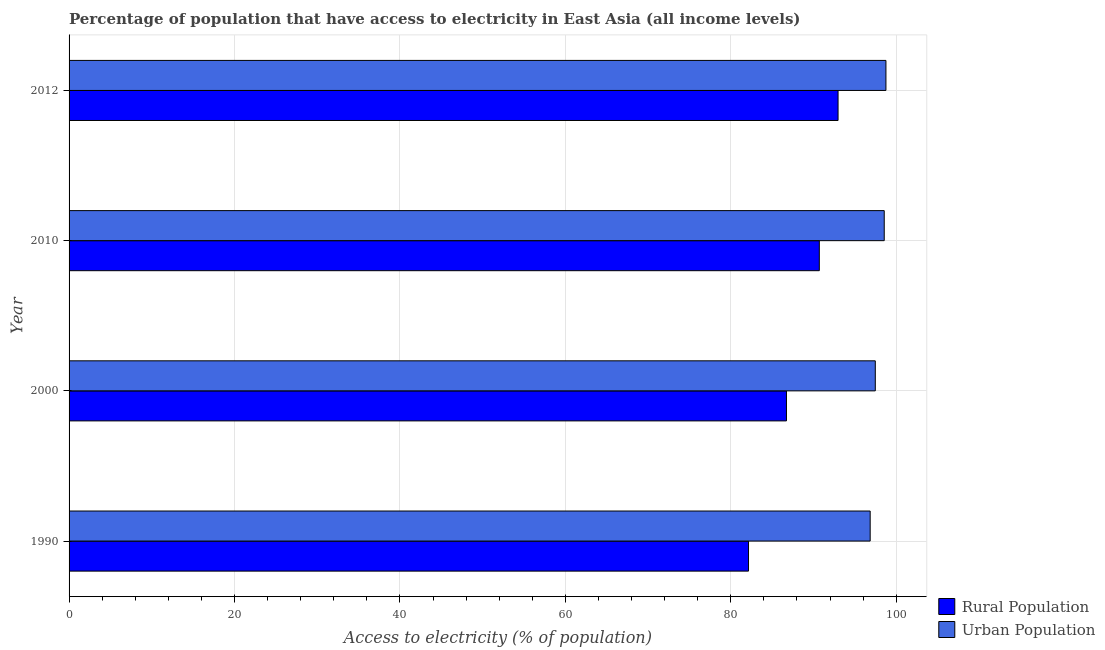Are the number of bars per tick equal to the number of legend labels?
Give a very brief answer. Yes. Are the number of bars on each tick of the Y-axis equal?
Your answer should be very brief. Yes. What is the label of the 2nd group of bars from the top?
Provide a succinct answer. 2010. In how many cases, is the number of bars for a given year not equal to the number of legend labels?
Your response must be concise. 0. What is the percentage of urban population having access to electricity in 2010?
Offer a terse response. 98.55. Across all years, what is the maximum percentage of urban population having access to electricity?
Your answer should be very brief. 98.76. Across all years, what is the minimum percentage of rural population having access to electricity?
Offer a terse response. 82.14. In which year was the percentage of urban population having access to electricity maximum?
Ensure brevity in your answer.  2012. What is the total percentage of urban population having access to electricity in the graph?
Provide a succinct answer. 391.62. What is the difference between the percentage of rural population having access to electricity in 2010 and that in 2012?
Your answer should be very brief. -2.27. What is the difference between the percentage of rural population having access to electricity in 2000 and the percentage of urban population having access to electricity in 2010?
Make the answer very short. -11.82. What is the average percentage of urban population having access to electricity per year?
Keep it short and to the point. 97.91. In the year 2012, what is the difference between the percentage of urban population having access to electricity and percentage of rural population having access to electricity?
Give a very brief answer. 5.79. In how many years, is the percentage of urban population having access to electricity greater than 44 %?
Offer a terse response. 4. What is the ratio of the percentage of urban population having access to electricity in 2010 to that in 2012?
Your answer should be compact. 1. What is the difference between the highest and the second highest percentage of urban population having access to electricity?
Your response must be concise. 0.21. What is the difference between the highest and the lowest percentage of urban population having access to electricity?
Your answer should be very brief. 1.9. In how many years, is the percentage of rural population having access to electricity greater than the average percentage of rural population having access to electricity taken over all years?
Offer a terse response. 2. What does the 1st bar from the top in 2010 represents?
Give a very brief answer. Urban Population. What does the 1st bar from the bottom in 2010 represents?
Give a very brief answer. Rural Population. How many bars are there?
Your answer should be very brief. 8. Are all the bars in the graph horizontal?
Your response must be concise. Yes. What is the difference between two consecutive major ticks on the X-axis?
Your answer should be very brief. 20. Does the graph contain any zero values?
Your answer should be very brief. No. How many legend labels are there?
Give a very brief answer. 2. How are the legend labels stacked?
Offer a very short reply. Vertical. What is the title of the graph?
Keep it short and to the point. Percentage of population that have access to electricity in East Asia (all income levels). What is the label or title of the X-axis?
Keep it short and to the point. Access to electricity (% of population). What is the label or title of the Y-axis?
Offer a terse response. Year. What is the Access to electricity (% of population) of Rural Population in 1990?
Your response must be concise. 82.14. What is the Access to electricity (% of population) in Urban Population in 1990?
Give a very brief answer. 96.85. What is the Access to electricity (% of population) in Rural Population in 2000?
Offer a very short reply. 86.73. What is the Access to electricity (% of population) in Urban Population in 2000?
Ensure brevity in your answer.  97.47. What is the Access to electricity (% of population) in Rural Population in 2010?
Your answer should be very brief. 90.7. What is the Access to electricity (% of population) in Urban Population in 2010?
Offer a very short reply. 98.55. What is the Access to electricity (% of population) in Rural Population in 2012?
Offer a very short reply. 92.97. What is the Access to electricity (% of population) of Urban Population in 2012?
Give a very brief answer. 98.76. Across all years, what is the maximum Access to electricity (% of population) of Rural Population?
Provide a short and direct response. 92.97. Across all years, what is the maximum Access to electricity (% of population) of Urban Population?
Your response must be concise. 98.76. Across all years, what is the minimum Access to electricity (% of population) in Rural Population?
Your answer should be very brief. 82.14. Across all years, what is the minimum Access to electricity (% of population) of Urban Population?
Make the answer very short. 96.85. What is the total Access to electricity (% of population) of Rural Population in the graph?
Make the answer very short. 352.54. What is the total Access to electricity (% of population) of Urban Population in the graph?
Provide a succinct answer. 391.62. What is the difference between the Access to electricity (% of population) in Rural Population in 1990 and that in 2000?
Ensure brevity in your answer.  -4.59. What is the difference between the Access to electricity (% of population) of Urban Population in 1990 and that in 2000?
Provide a short and direct response. -0.62. What is the difference between the Access to electricity (% of population) in Rural Population in 1990 and that in 2010?
Make the answer very short. -8.56. What is the difference between the Access to electricity (% of population) of Urban Population in 1990 and that in 2010?
Your answer should be compact. -1.7. What is the difference between the Access to electricity (% of population) in Rural Population in 1990 and that in 2012?
Keep it short and to the point. -10.83. What is the difference between the Access to electricity (% of population) of Urban Population in 1990 and that in 2012?
Provide a succinct answer. -1.9. What is the difference between the Access to electricity (% of population) of Rural Population in 2000 and that in 2010?
Provide a succinct answer. -3.97. What is the difference between the Access to electricity (% of population) of Urban Population in 2000 and that in 2010?
Offer a terse response. -1.08. What is the difference between the Access to electricity (% of population) in Rural Population in 2000 and that in 2012?
Your answer should be compact. -6.24. What is the difference between the Access to electricity (% of population) in Urban Population in 2000 and that in 2012?
Your response must be concise. -1.29. What is the difference between the Access to electricity (% of population) of Rural Population in 2010 and that in 2012?
Give a very brief answer. -2.27. What is the difference between the Access to electricity (% of population) of Urban Population in 2010 and that in 2012?
Give a very brief answer. -0.21. What is the difference between the Access to electricity (% of population) in Rural Population in 1990 and the Access to electricity (% of population) in Urban Population in 2000?
Ensure brevity in your answer.  -15.33. What is the difference between the Access to electricity (% of population) of Rural Population in 1990 and the Access to electricity (% of population) of Urban Population in 2010?
Give a very brief answer. -16.41. What is the difference between the Access to electricity (% of population) of Rural Population in 1990 and the Access to electricity (% of population) of Urban Population in 2012?
Offer a terse response. -16.61. What is the difference between the Access to electricity (% of population) of Rural Population in 2000 and the Access to electricity (% of population) of Urban Population in 2010?
Provide a succinct answer. -11.82. What is the difference between the Access to electricity (% of population) in Rural Population in 2000 and the Access to electricity (% of population) in Urban Population in 2012?
Provide a succinct answer. -12.02. What is the difference between the Access to electricity (% of population) of Rural Population in 2010 and the Access to electricity (% of population) of Urban Population in 2012?
Offer a very short reply. -8.05. What is the average Access to electricity (% of population) in Rural Population per year?
Your answer should be very brief. 88.14. What is the average Access to electricity (% of population) of Urban Population per year?
Give a very brief answer. 97.91. In the year 1990, what is the difference between the Access to electricity (% of population) in Rural Population and Access to electricity (% of population) in Urban Population?
Your answer should be very brief. -14.71. In the year 2000, what is the difference between the Access to electricity (% of population) in Rural Population and Access to electricity (% of population) in Urban Population?
Your response must be concise. -10.74. In the year 2010, what is the difference between the Access to electricity (% of population) of Rural Population and Access to electricity (% of population) of Urban Population?
Ensure brevity in your answer.  -7.85. In the year 2012, what is the difference between the Access to electricity (% of population) of Rural Population and Access to electricity (% of population) of Urban Population?
Your response must be concise. -5.79. What is the ratio of the Access to electricity (% of population) in Rural Population in 1990 to that in 2000?
Keep it short and to the point. 0.95. What is the ratio of the Access to electricity (% of population) in Urban Population in 1990 to that in 2000?
Offer a very short reply. 0.99. What is the ratio of the Access to electricity (% of population) of Rural Population in 1990 to that in 2010?
Offer a terse response. 0.91. What is the ratio of the Access to electricity (% of population) of Urban Population in 1990 to that in 2010?
Provide a succinct answer. 0.98. What is the ratio of the Access to electricity (% of population) of Rural Population in 1990 to that in 2012?
Give a very brief answer. 0.88. What is the ratio of the Access to electricity (% of population) of Urban Population in 1990 to that in 2012?
Offer a very short reply. 0.98. What is the ratio of the Access to electricity (% of population) of Rural Population in 2000 to that in 2010?
Your response must be concise. 0.96. What is the ratio of the Access to electricity (% of population) in Urban Population in 2000 to that in 2010?
Offer a very short reply. 0.99. What is the ratio of the Access to electricity (% of population) of Rural Population in 2000 to that in 2012?
Offer a terse response. 0.93. What is the ratio of the Access to electricity (% of population) in Urban Population in 2000 to that in 2012?
Offer a very short reply. 0.99. What is the ratio of the Access to electricity (% of population) in Rural Population in 2010 to that in 2012?
Make the answer very short. 0.98. What is the ratio of the Access to electricity (% of population) in Urban Population in 2010 to that in 2012?
Keep it short and to the point. 1. What is the difference between the highest and the second highest Access to electricity (% of population) of Rural Population?
Give a very brief answer. 2.27. What is the difference between the highest and the second highest Access to electricity (% of population) of Urban Population?
Give a very brief answer. 0.21. What is the difference between the highest and the lowest Access to electricity (% of population) of Rural Population?
Provide a short and direct response. 10.83. What is the difference between the highest and the lowest Access to electricity (% of population) of Urban Population?
Give a very brief answer. 1.9. 